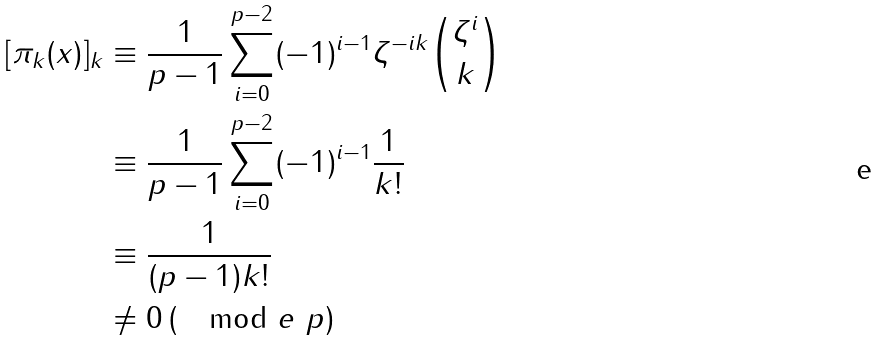Convert formula to latex. <formula><loc_0><loc_0><loc_500><loc_500>[ \pi _ { k } ( x ) ] _ { k } & \equiv \frac { 1 } { p - 1 } \sum _ { i = 0 } ^ { p - 2 } ( - 1 ) ^ { i - 1 } \zeta ^ { - i k } { \zeta ^ { i } \choose k } \\ & \equiv \frac { 1 } { p - 1 } \sum _ { i = 0 } ^ { p - 2 } ( - 1 ) ^ { i - 1 } \frac { 1 } { k ! } \\ & \equiv \frac { 1 } { ( p - 1 ) k ! } \\ & \neq 0 \, ( \mod e \ p )</formula> 